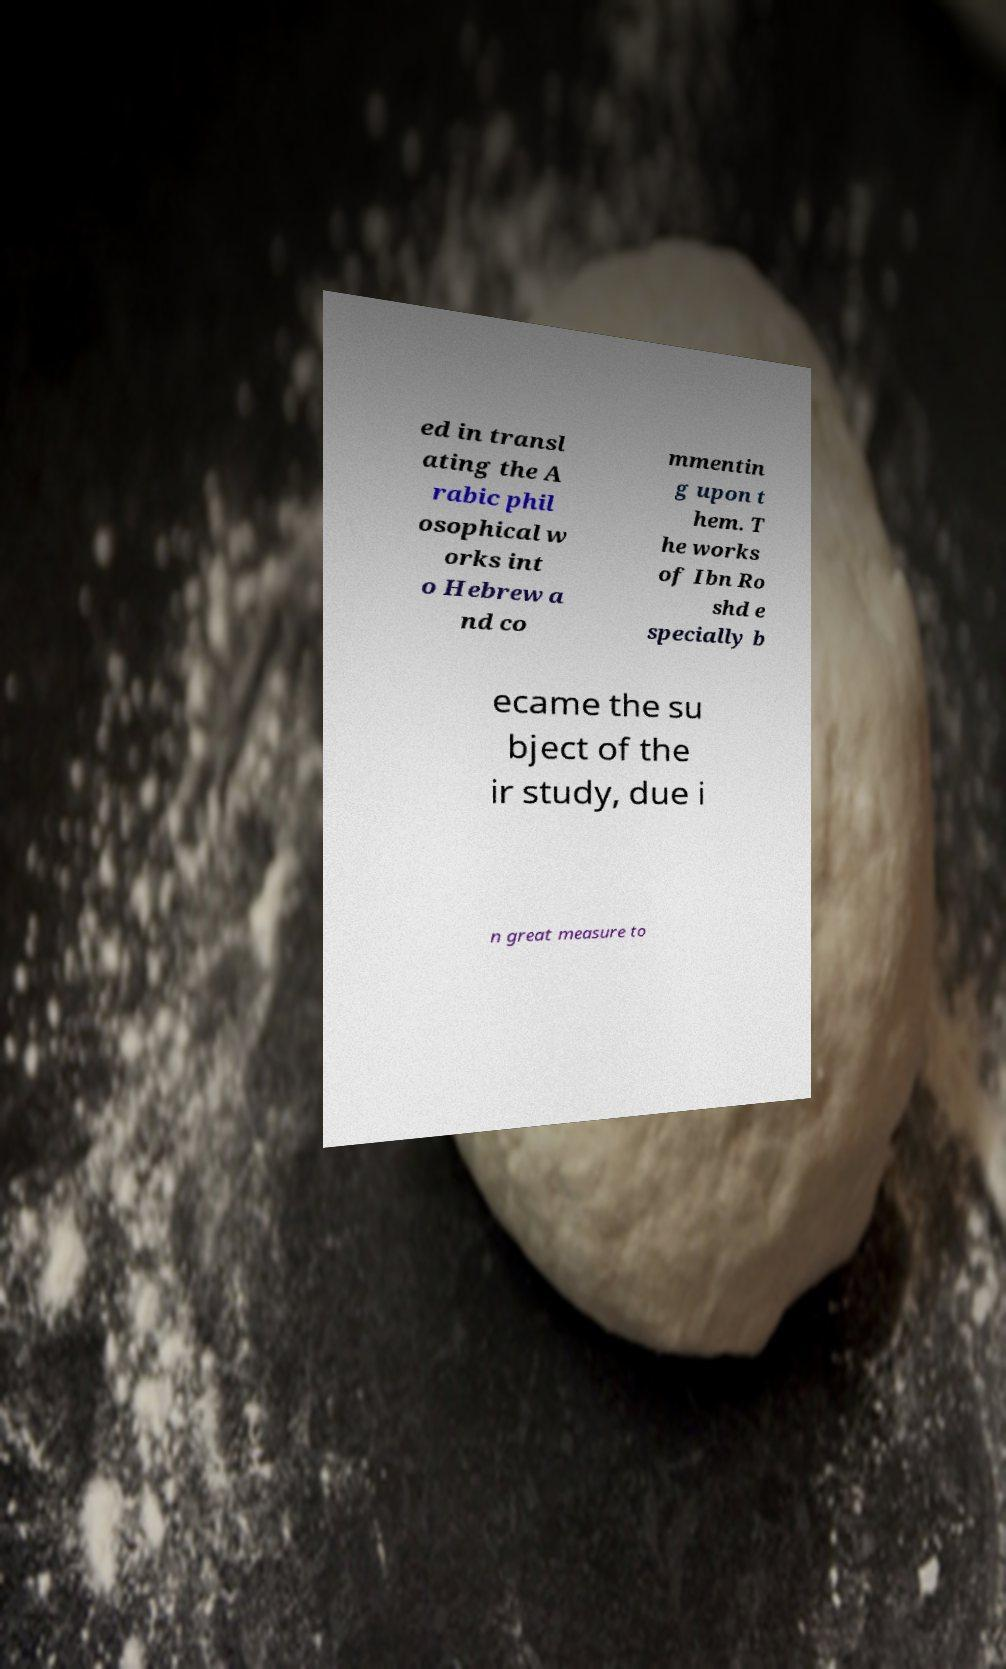Can you accurately transcribe the text from the provided image for me? ed in transl ating the A rabic phil osophical w orks int o Hebrew a nd co mmentin g upon t hem. T he works of Ibn Ro shd e specially b ecame the su bject of the ir study, due i n great measure to 